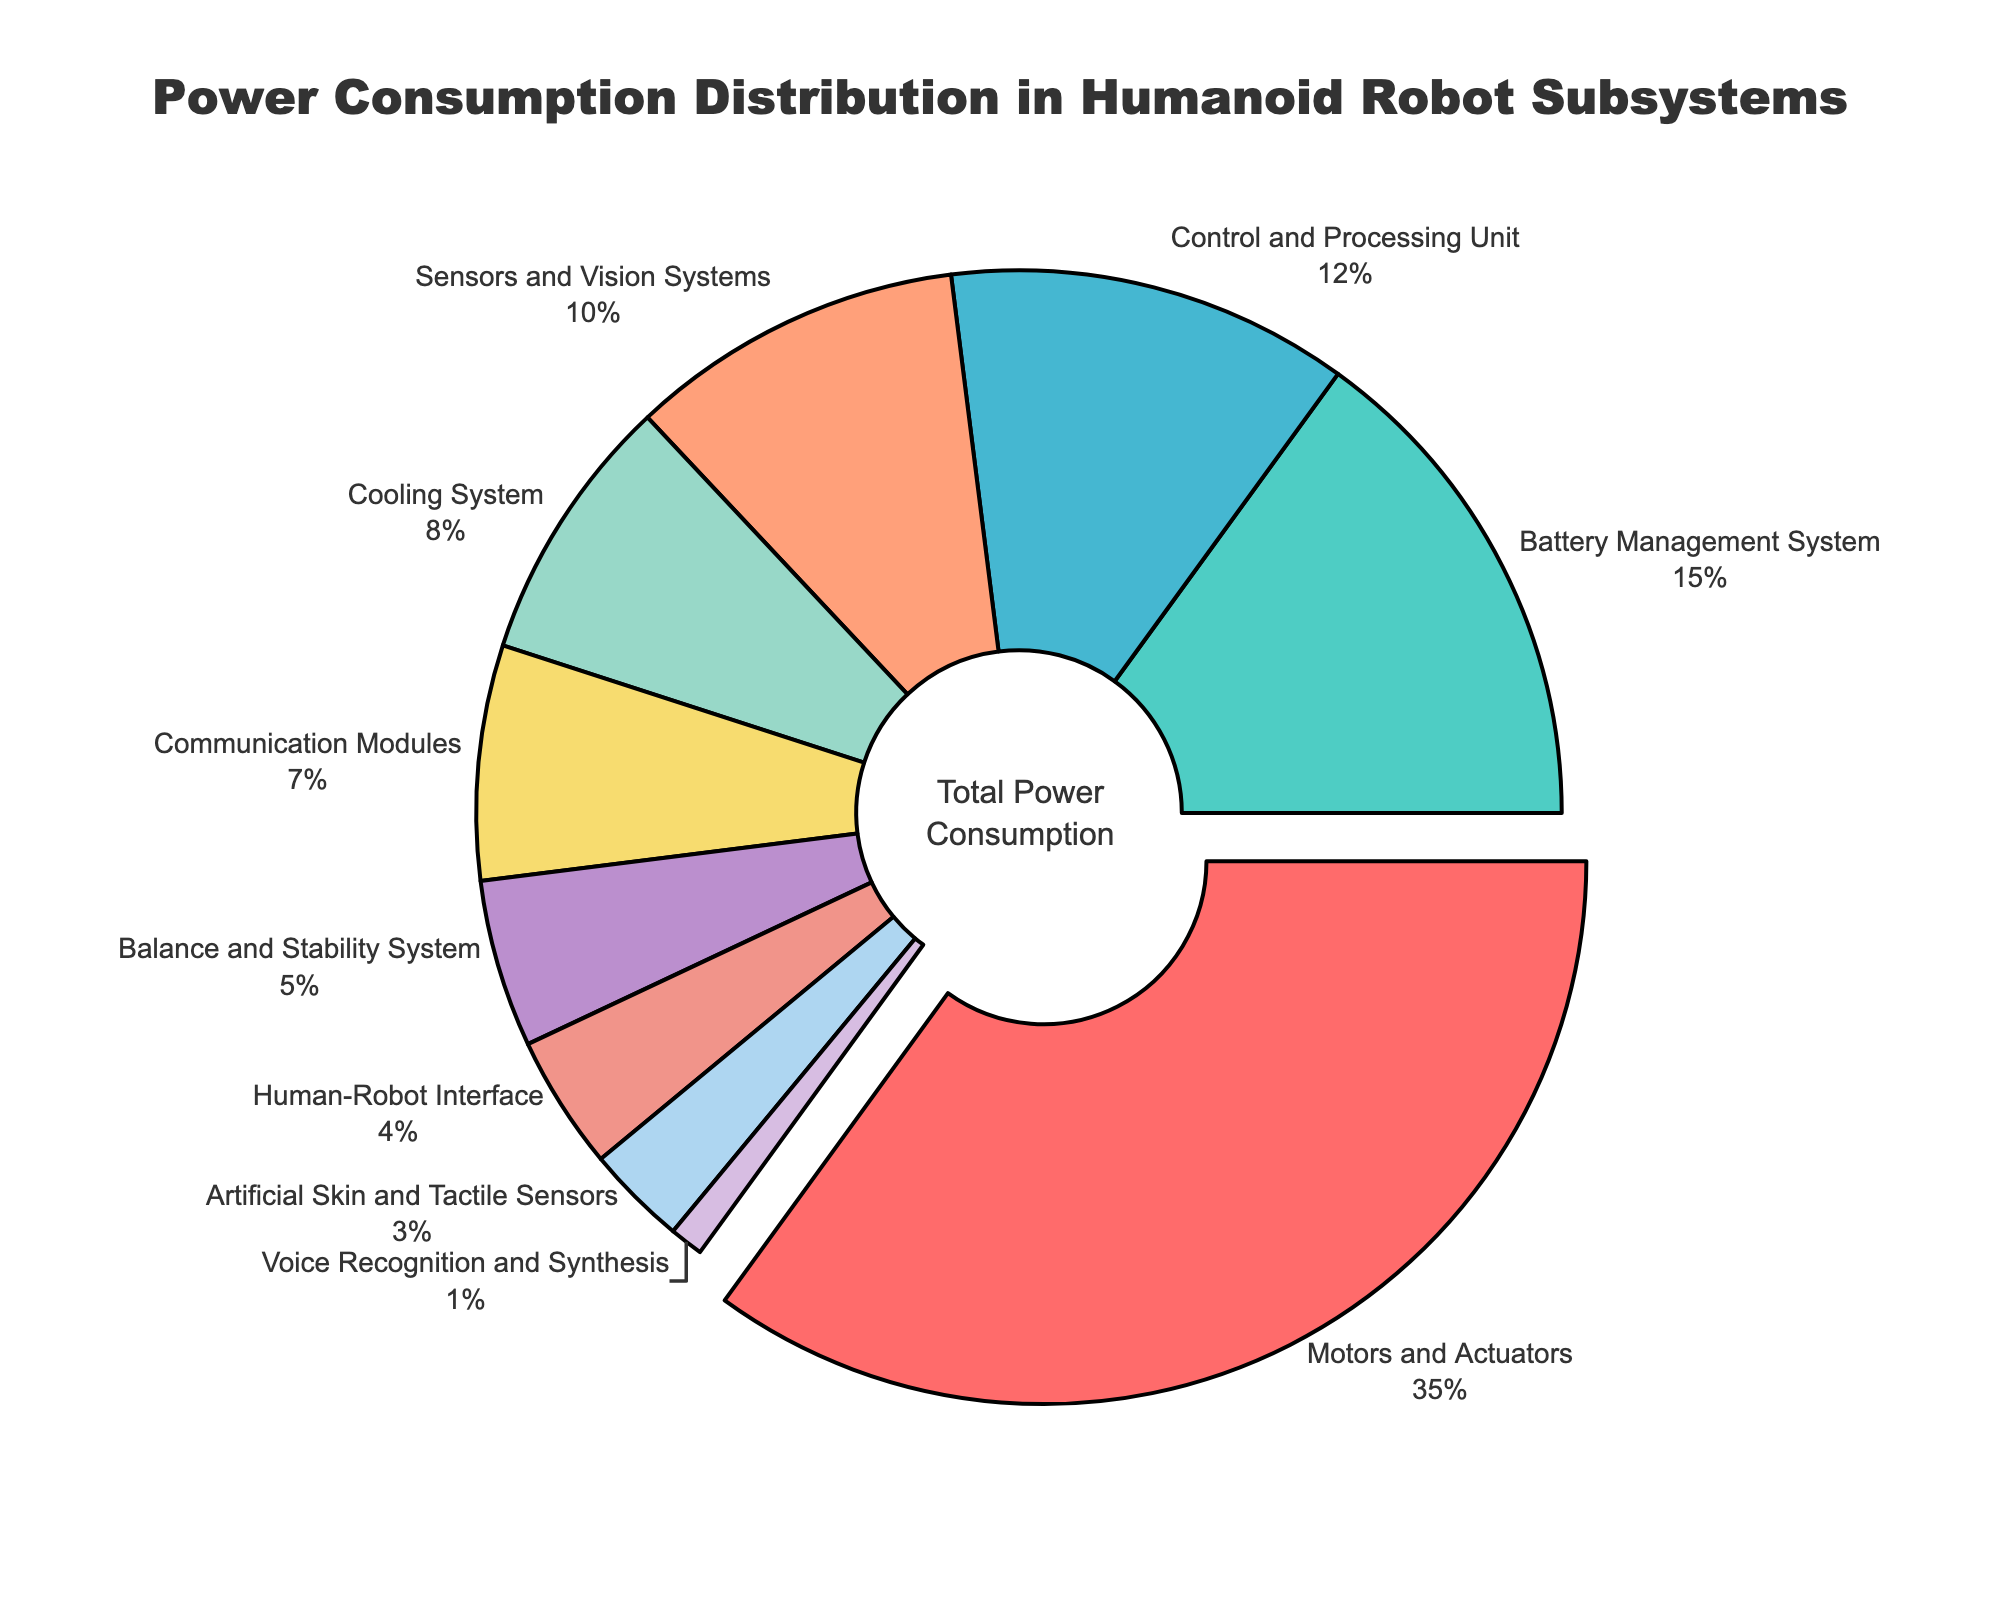Which subsystem consumes the highest percentage of power? The figure shows that "Motors and Actuators" have a separate section pulled out with the highest percentage indicated.
Answer: Motors and Actuators How much more power does the Motors and Actuators subsystem consume compared to the Cooling System? The figure shows that Motors and Actuators consume 35%, and the Cooling System consumes 8%. The difference is 35% - 8% = 27%.
Answer: 27% What is the combined power consumption percentage of the Control and Processing Unit and the Sensors and Vision Systems? The Control and Processing Unit consumes 12% and the Sensors and Vision Systems consume 10%. Adding them together: 12% + 10% = 22%.
Answer: 22% Which two subsystems consume less than 5% of the total power? Both "Human-Robot Interface" and "Artificial Skin and Tactile Sensors" fall into this category. Human-Robot Interface consumes 4%, and Artificial Skin and Tactile Sensors consume 3%.
Answer: Human-Robot Interface and Artificial Skin and Tactile Sensors Is the power consumption of the Battery Management System greater than the power consumption of the Communication Modules? The figure shows that the Battery Management System consumes 15%, and the Communication Modules consume 7%. 15% is greater than 7%.
Answer: Yes How many subsystems consume more than 10% of power each, and which are they? By examining the power consumption percentages, only three subsystems consume more than 10%: Motors and Actuators (35%), Battery Management System (15%), and Control and Processing Unit (12%).
Answer: 3 subsystems: Motors and Actuators, Battery Management System, Control and Processing Unit What percentage of power is consumed by the smallest and largest subsystems combined? The smallest is Voice Recognition and Synthesis with 1%, and the largest is Motors and Actuators with 35%. Combined: 1% + 35% = 36%.
Answer: 36% Is the power consumption of the Cooling System closer to the power consumption of the Sensors and Vision Systems or the Communication Modules? The Cooling System consumes 8%. Sensors and Vision Systems consume 10% and Communication Modules consume 7%. The difference between Cooling System and Sensors and Vision Systems is 2% (10% - 8%), and the difference between Cooling System and Communication Modules is 1% (8% - 7%). 1% is closer than 2%.
Answer: Communication Modules Does the Human-Robot Interface consume more or less power than the Balance and Stability System? The figure shows that the Human-Robot Interface consumes 4%, and the Balance and Stability System consumes 5%. 4% is less than 5%.
Answer: Less What is the total power consumption of the subsystems that consume less than 10% each except for the largest and smallest subsystems? The subsystems are Cooling System (8%), Communication Modules (7%), Balance and Stability System (5%), Human-Robot Interface (4%), Artificial Skin and Tactile Sensors (3%). Adding these: 8% + 7% + 5% + 4% + 3% = 27%.
Answer: 27% 